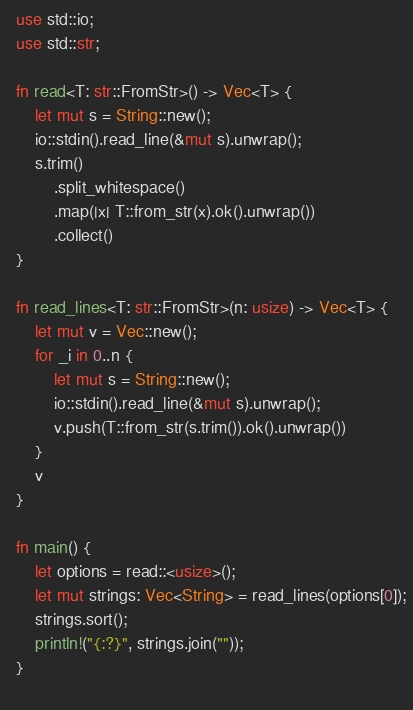<code> <loc_0><loc_0><loc_500><loc_500><_Rust_>  use std::io;
  use std::str;
  
  fn read<T: str::FromStr>() -> Vec<T> {
      let mut s = String::new();
      io::stdin().read_line(&mut s).unwrap();
      s.trim()
          .split_whitespace()
          .map(|x| T::from_str(x).ok().unwrap())
          .collect()
  }
  
  fn read_lines<T: str::FromStr>(n: usize) -> Vec<T> {
      let mut v = Vec::new();
      for _i in 0..n { 
          let mut s = String::new();
          io::stdin().read_line(&mut s).unwrap();
          v.push(T::from_str(s.trim()).ok().unwrap())
      }
      v
  }
  
  fn main() {
      let options = read::<usize>();
      let mut strings: Vec<String> = read_lines(options[0]);
      strings.sort();
      println!("{:?}", strings.join(""));
  }
 
</code> 